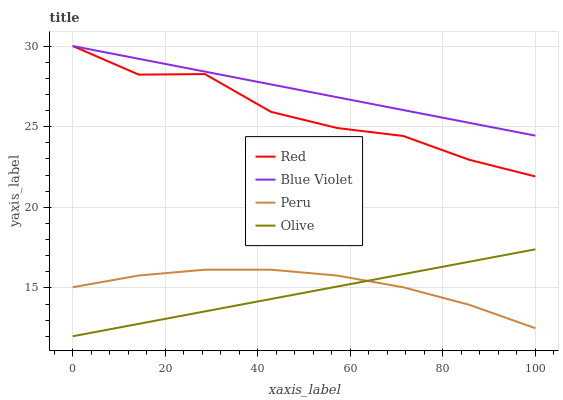Does Olive have the minimum area under the curve?
Answer yes or no. Yes. Does Blue Violet have the maximum area under the curve?
Answer yes or no. Yes. Does Peru have the minimum area under the curve?
Answer yes or no. No. Does Peru have the maximum area under the curve?
Answer yes or no. No. Is Blue Violet the smoothest?
Answer yes or no. Yes. Is Red the roughest?
Answer yes or no. Yes. Is Peru the smoothest?
Answer yes or no. No. Is Peru the roughest?
Answer yes or no. No. Does Olive have the lowest value?
Answer yes or no. Yes. Does Peru have the lowest value?
Answer yes or no. No. Does Red have the highest value?
Answer yes or no. Yes. Does Peru have the highest value?
Answer yes or no. No. Is Olive less than Blue Violet?
Answer yes or no. Yes. Is Red greater than Olive?
Answer yes or no. Yes. Does Blue Violet intersect Red?
Answer yes or no. Yes. Is Blue Violet less than Red?
Answer yes or no. No. Is Blue Violet greater than Red?
Answer yes or no. No. Does Olive intersect Blue Violet?
Answer yes or no. No. 